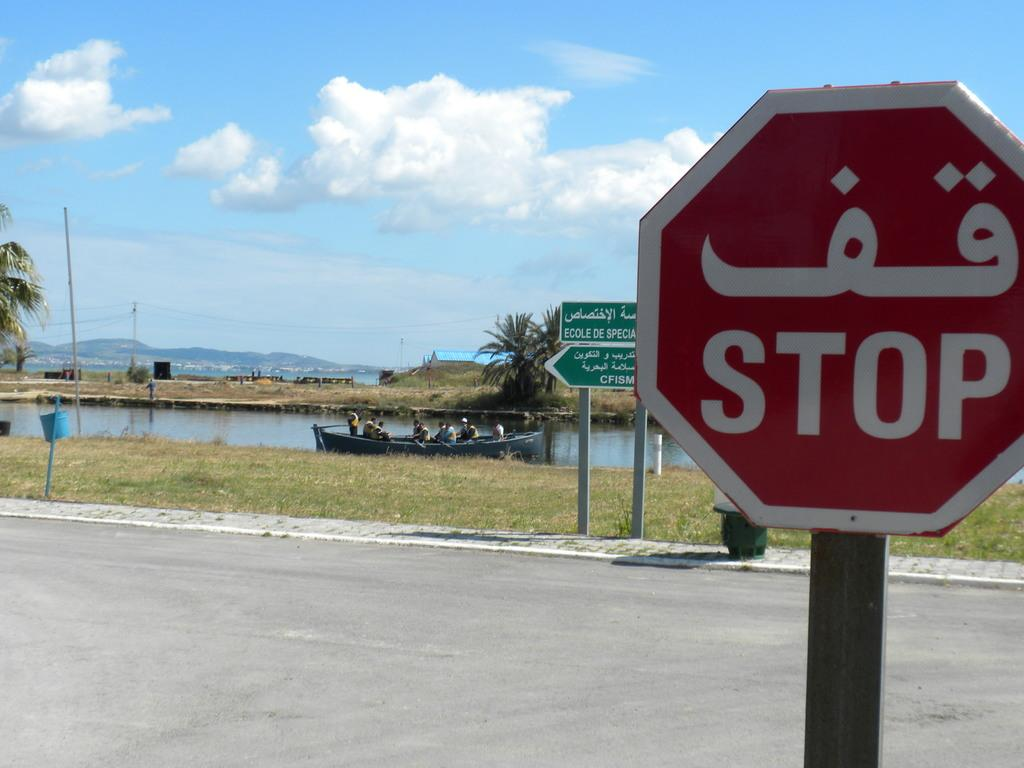Provide a one-sentence caption for the provided image. A stop sign in front of a river with a boat. 